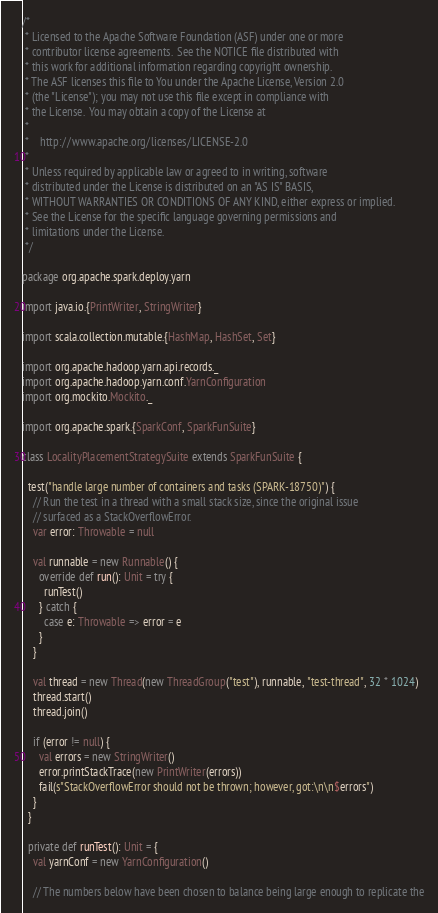<code> <loc_0><loc_0><loc_500><loc_500><_Scala_>/*
 * Licensed to the Apache Software Foundation (ASF) under one or more
 * contributor license agreements.  See the NOTICE file distributed with
 * this work for additional information regarding copyright ownership.
 * The ASF licenses this file to You under the Apache License, Version 2.0
 * (the "License"); you may not use this file except in compliance with
 * the License.  You may obtain a copy of the License at
 *
 *    http://www.apache.org/licenses/LICENSE-2.0
 *
 * Unless required by applicable law or agreed to in writing, software
 * distributed under the License is distributed on an "AS IS" BASIS,
 * WITHOUT WARRANTIES OR CONDITIONS OF ANY KIND, either express or implied.
 * See the License for the specific language governing permissions and
 * limitations under the License.
 */

package org.apache.spark.deploy.yarn

import java.io.{PrintWriter, StringWriter}

import scala.collection.mutable.{HashMap, HashSet, Set}

import org.apache.hadoop.yarn.api.records._
import org.apache.hadoop.yarn.conf.YarnConfiguration
import org.mockito.Mockito._

import org.apache.spark.{SparkConf, SparkFunSuite}

class LocalityPlacementStrategySuite extends SparkFunSuite {

  test("handle large number of containers and tasks (SPARK-18750)") {
    // Run the test in a thread with a small stack size, since the original issue
    // surfaced as a StackOverflowError.
    var error: Throwable = null

    val runnable = new Runnable() {
      override def run(): Unit = try {
        runTest()
      } catch {
        case e: Throwable => error = e
      }
    }

    val thread = new Thread(new ThreadGroup("test"), runnable, "test-thread", 32 * 1024)
    thread.start()
    thread.join()

    if (error != null) {
      val errors = new StringWriter()
      error.printStackTrace(new PrintWriter(errors))
      fail(s"StackOverflowError should not be thrown; however, got:\n\n$errors")
    }
  }

  private def runTest(): Unit = {
    val yarnConf = new YarnConfiguration()

    // The numbers below have been chosen to balance being large enough to replicate the</code> 